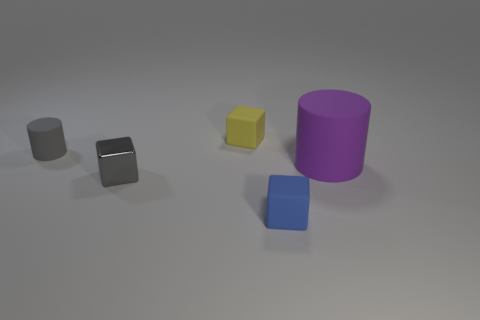Which is the largest object and why does it appear so? The purple cylinder is the largest object in the image due to its height and volume compared to the other objects, which are smaller and have a cube-like shape. Its considerable size relative to the other items is evident by assessing the amount of space it occupies visually. 